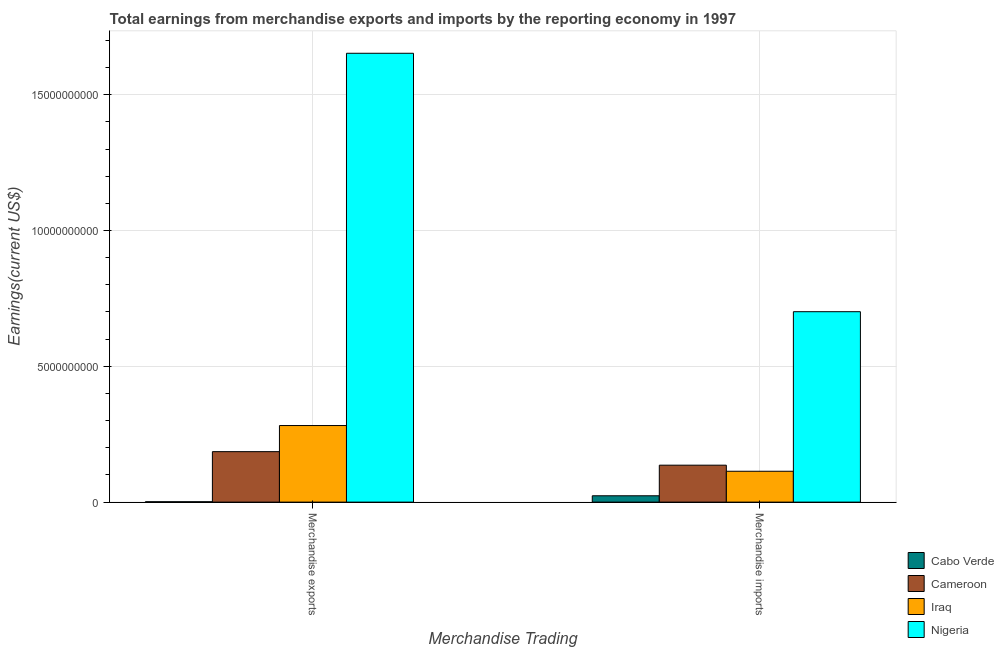Are the number of bars per tick equal to the number of legend labels?
Ensure brevity in your answer.  Yes. Are the number of bars on each tick of the X-axis equal?
Your response must be concise. Yes. What is the earnings from merchandise exports in Nigeria?
Provide a short and direct response. 1.65e+1. Across all countries, what is the maximum earnings from merchandise imports?
Make the answer very short. 7.01e+09. Across all countries, what is the minimum earnings from merchandise exports?
Offer a very short reply. 1.39e+07. In which country was the earnings from merchandise imports maximum?
Provide a short and direct response. Nigeria. In which country was the earnings from merchandise exports minimum?
Your response must be concise. Cabo Verde. What is the total earnings from merchandise exports in the graph?
Offer a terse response. 2.12e+1. What is the difference between the earnings from merchandise exports in Nigeria and that in Cameroon?
Keep it short and to the point. 1.47e+1. What is the difference between the earnings from merchandise exports in Nigeria and the earnings from merchandise imports in Cameroon?
Provide a succinct answer. 1.52e+1. What is the average earnings from merchandise exports per country?
Provide a short and direct response. 5.30e+09. What is the difference between the earnings from merchandise exports and earnings from merchandise imports in Cameroon?
Your answer should be compact. 4.98e+08. In how many countries, is the earnings from merchandise exports greater than 11000000000 US$?
Provide a short and direct response. 1. What is the ratio of the earnings from merchandise exports in Cameroon to that in Cabo Verde?
Offer a terse response. 133.65. Is the earnings from merchandise exports in Cameroon less than that in Iraq?
Provide a short and direct response. Yes. What does the 3rd bar from the left in Merchandise exports represents?
Your response must be concise. Iraq. What does the 3rd bar from the right in Merchandise imports represents?
Your answer should be compact. Cameroon. Are the values on the major ticks of Y-axis written in scientific E-notation?
Offer a terse response. No. Does the graph contain any zero values?
Make the answer very short. No. Where does the legend appear in the graph?
Ensure brevity in your answer.  Bottom right. How many legend labels are there?
Provide a succinct answer. 4. How are the legend labels stacked?
Keep it short and to the point. Vertical. What is the title of the graph?
Offer a terse response. Total earnings from merchandise exports and imports by the reporting economy in 1997. What is the label or title of the X-axis?
Provide a short and direct response. Merchandise Trading. What is the label or title of the Y-axis?
Your response must be concise. Earnings(current US$). What is the Earnings(current US$) of Cabo Verde in Merchandise exports?
Offer a terse response. 1.39e+07. What is the Earnings(current US$) of Cameroon in Merchandise exports?
Your response must be concise. 1.86e+09. What is the Earnings(current US$) of Iraq in Merchandise exports?
Your answer should be very brief. 2.82e+09. What is the Earnings(current US$) of Nigeria in Merchandise exports?
Keep it short and to the point. 1.65e+1. What is the Earnings(current US$) in Cabo Verde in Merchandise imports?
Your answer should be compact. 2.34e+08. What is the Earnings(current US$) in Cameroon in Merchandise imports?
Give a very brief answer. 1.36e+09. What is the Earnings(current US$) in Iraq in Merchandise imports?
Provide a succinct answer. 1.14e+09. What is the Earnings(current US$) in Nigeria in Merchandise imports?
Give a very brief answer. 7.01e+09. Across all Merchandise Trading, what is the maximum Earnings(current US$) in Cabo Verde?
Your answer should be very brief. 2.34e+08. Across all Merchandise Trading, what is the maximum Earnings(current US$) of Cameroon?
Give a very brief answer. 1.86e+09. Across all Merchandise Trading, what is the maximum Earnings(current US$) in Iraq?
Make the answer very short. 2.82e+09. Across all Merchandise Trading, what is the maximum Earnings(current US$) of Nigeria?
Your answer should be very brief. 1.65e+1. Across all Merchandise Trading, what is the minimum Earnings(current US$) of Cabo Verde?
Your answer should be compact. 1.39e+07. Across all Merchandise Trading, what is the minimum Earnings(current US$) in Cameroon?
Offer a very short reply. 1.36e+09. Across all Merchandise Trading, what is the minimum Earnings(current US$) in Iraq?
Your answer should be very brief. 1.14e+09. Across all Merchandise Trading, what is the minimum Earnings(current US$) in Nigeria?
Your answer should be very brief. 7.01e+09. What is the total Earnings(current US$) of Cabo Verde in the graph?
Your answer should be compact. 2.47e+08. What is the total Earnings(current US$) of Cameroon in the graph?
Keep it short and to the point. 3.22e+09. What is the total Earnings(current US$) of Iraq in the graph?
Keep it short and to the point. 3.96e+09. What is the total Earnings(current US$) of Nigeria in the graph?
Make the answer very short. 2.35e+1. What is the difference between the Earnings(current US$) in Cabo Verde in Merchandise exports and that in Merchandise imports?
Provide a succinct answer. -2.20e+08. What is the difference between the Earnings(current US$) of Cameroon in Merchandise exports and that in Merchandise imports?
Offer a terse response. 4.98e+08. What is the difference between the Earnings(current US$) in Iraq in Merchandise exports and that in Merchandise imports?
Your answer should be compact. 1.68e+09. What is the difference between the Earnings(current US$) in Nigeria in Merchandise exports and that in Merchandise imports?
Your response must be concise. 9.51e+09. What is the difference between the Earnings(current US$) of Cabo Verde in Merchandise exports and the Earnings(current US$) of Cameroon in Merchandise imports?
Provide a short and direct response. -1.35e+09. What is the difference between the Earnings(current US$) of Cabo Verde in Merchandise exports and the Earnings(current US$) of Iraq in Merchandise imports?
Provide a succinct answer. -1.12e+09. What is the difference between the Earnings(current US$) in Cabo Verde in Merchandise exports and the Earnings(current US$) in Nigeria in Merchandise imports?
Give a very brief answer. -7.00e+09. What is the difference between the Earnings(current US$) in Cameroon in Merchandise exports and the Earnings(current US$) in Iraq in Merchandise imports?
Your answer should be very brief. 7.22e+08. What is the difference between the Earnings(current US$) of Cameroon in Merchandise exports and the Earnings(current US$) of Nigeria in Merchandise imports?
Your response must be concise. -5.15e+09. What is the difference between the Earnings(current US$) of Iraq in Merchandise exports and the Earnings(current US$) of Nigeria in Merchandise imports?
Ensure brevity in your answer.  -4.19e+09. What is the average Earnings(current US$) in Cabo Verde per Merchandise Trading?
Provide a succinct answer. 1.24e+08. What is the average Earnings(current US$) of Cameroon per Merchandise Trading?
Your response must be concise. 1.61e+09. What is the average Earnings(current US$) in Iraq per Merchandise Trading?
Offer a terse response. 1.98e+09. What is the average Earnings(current US$) in Nigeria per Merchandise Trading?
Make the answer very short. 1.18e+1. What is the difference between the Earnings(current US$) in Cabo Verde and Earnings(current US$) in Cameroon in Merchandise exports?
Offer a terse response. -1.84e+09. What is the difference between the Earnings(current US$) of Cabo Verde and Earnings(current US$) of Iraq in Merchandise exports?
Keep it short and to the point. -2.81e+09. What is the difference between the Earnings(current US$) of Cabo Verde and Earnings(current US$) of Nigeria in Merchandise exports?
Make the answer very short. -1.65e+1. What is the difference between the Earnings(current US$) in Cameroon and Earnings(current US$) in Iraq in Merchandise exports?
Your response must be concise. -9.61e+08. What is the difference between the Earnings(current US$) of Cameroon and Earnings(current US$) of Nigeria in Merchandise exports?
Give a very brief answer. -1.47e+1. What is the difference between the Earnings(current US$) in Iraq and Earnings(current US$) in Nigeria in Merchandise exports?
Give a very brief answer. -1.37e+1. What is the difference between the Earnings(current US$) in Cabo Verde and Earnings(current US$) in Cameroon in Merchandise imports?
Offer a terse response. -1.13e+09. What is the difference between the Earnings(current US$) of Cabo Verde and Earnings(current US$) of Iraq in Merchandise imports?
Provide a short and direct response. -9.03e+08. What is the difference between the Earnings(current US$) in Cabo Verde and Earnings(current US$) in Nigeria in Merchandise imports?
Provide a succinct answer. -6.78e+09. What is the difference between the Earnings(current US$) in Cameroon and Earnings(current US$) in Iraq in Merchandise imports?
Keep it short and to the point. 2.24e+08. What is the difference between the Earnings(current US$) in Cameroon and Earnings(current US$) in Nigeria in Merchandise imports?
Your answer should be compact. -5.65e+09. What is the difference between the Earnings(current US$) in Iraq and Earnings(current US$) in Nigeria in Merchandise imports?
Your response must be concise. -5.87e+09. What is the ratio of the Earnings(current US$) in Cabo Verde in Merchandise exports to that in Merchandise imports?
Your answer should be compact. 0.06. What is the ratio of the Earnings(current US$) in Cameroon in Merchandise exports to that in Merchandise imports?
Provide a short and direct response. 1.37. What is the ratio of the Earnings(current US$) in Iraq in Merchandise exports to that in Merchandise imports?
Ensure brevity in your answer.  2.48. What is the ratio of the Earnings(current US$) of Nigeria in Merchandise exports to that in Merchandise imports?
Make the answer very short. 2.36. What is the difference between the highest and the second highest Earnings(current US$) in Cabo Verde?
Ensure brevity in your answer.  2.20e+08. What is the difference between the highest and the second highest Earnings(current US$) of Cameroon?
Your answer should be very brief. 4.98e+08. What is the difference between the highest and the second highest Earnings(current US$) of Iraq?
Make the answer very short. 1.68e+09. What is the difference between the highest and the second highest Earnings(current US$) in Nigeria?
Offer a very short reply. 9.51e+09. What is the difference between the highest and the lowest Earnings(current US$) in Cabo Verde?
Provide a succinct answer. 2.20e+08. What is the difference between the highest and the lowest Earnings(current US$) in Cameroon?
Provide a short and direct response. 4.98e+08. What is the difference between the highest and the lowest Earnings(current US$) of Iraq?
Your answer should be compact. 1.68e+09. What is the difference between the highest and the lowest Earnings(current US$) in Nigeria?
Your answer should be compact. 9.51e+09. 